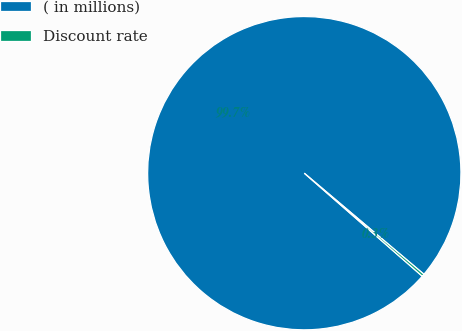Convert chart. <chart><loc_0><loc_0><loc_500><loc_500><pie_chart><fcel>( in millions)<fcel>Discount rate<nl><fcel>99.74%<fcel>0.26%<nl></chart> 